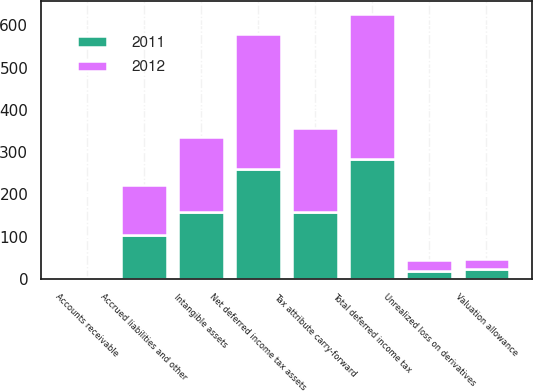Convert chart. <chart><loc_0><loc_0><loc_500><loc_500><stacked_bar_chart><ecel><fcel>Accounts receivable<fcel>Tax attribute carry-forward<fcel>Unrealized loss on derivatives<fcel>Accrued liabilities and other<fcel>Total deferred income tax<fcel>Valuation allowance<fcel>Net deferred income tax assets<fcel>Intangible assets<nl><fcel>2012<fcel>2<fcel>198<fcel>26<fcel>117<fcel>343<fcel>23<fcel>320<fcel>178<nl><fcel>2011<fcel>2<fcel>158<fcel>19<fcel>105<fcel>284<fcel>24<fcel>260<fcel>158<nl></chart> 